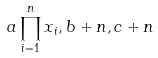Convert formula to latex. <formula><loc_0><loc_0><loc_500><loc_500>a \prod _ { i = 1 } ^ { n } x _ { i } , b + n , c + n</formula> 